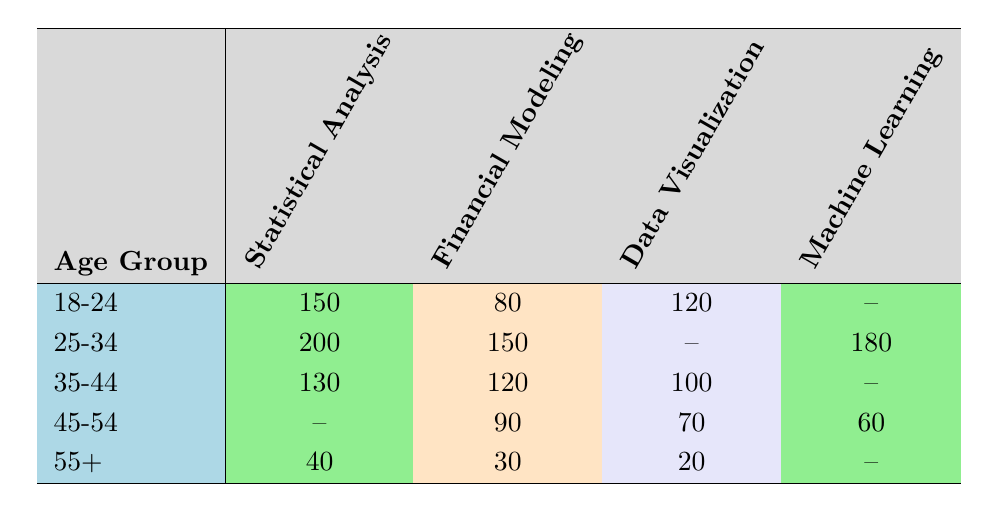What is the count of users in the 25-34 age group who prefer Financial Modeling? Referring to the table, the count for the age group 25-34 under the Financial Modeling category is 150.
Answer: 150 What is the preferred application among the 45-54 age group with the highest user count? Looking at the row for the age group 45-54, the highest count is 90 for Financial Modeling.
Answer: Financial Modeling How many users aged 35-44 prefer Data Visualization? According to the table, the count for the age group 35-44 under Data Visualization is 100.
Answer: 100 What is the total count of users aged 18-24 preferring Statistical Analysis and Data Visualization combined? In the table, the count for Statistical Analysis for the 18-24 age group is 150 and for Data Visualization is 120. Adding these gives 150 + 120 = 270.
Answer: 270 Is there any age group that does not prefer Machine Learning? By checking the table, the 18-24 and the 35-44 age groups do not have a count for Machine Learning, which indicates they do not prefer it.
Answer: Yes What is the average number of users across all age groups that prefer Financial Modeling? We sum the counts for Financial Modeling by age groups: 80 (18-24) + 150 (25-34) + 120 (35-44) + 90 (45-54) + 30 (55+) = 470. Then, dividing this by the number of age groups (5) gives an average of 470 / 5 = 94.
Answer: 94 What is the total count of users who prefer Statistical Analysis across all age groups? We examine the counts for Statistical Analysis: 150 (18-24) + 200 (25-34) + 130 (35-44) + 0 (45-54, no entry) + 40 (55+) = 520.
Answer: 520 What is the difference in user preference between Data Visualization and Machine Learning for the 25-34 age group? In the table, Data Visualization has a count of 0 under the 25-34 age group, while Machine Learning has a count of 180. The difference is 180 - 0 = 180.
Answer: 180 What percentage of users aged 55+ prefer Financial Modeling? The count of users aged 55+ is 30 for Financial Modeling. The total count for this age group is 30 (Financial Modeling) + 20 (Data Visualization) + 40 (Statistical Analysis) = 90. The percentage is (30 / 90) * 100 = 33.33%.
Answer: 33.33% 